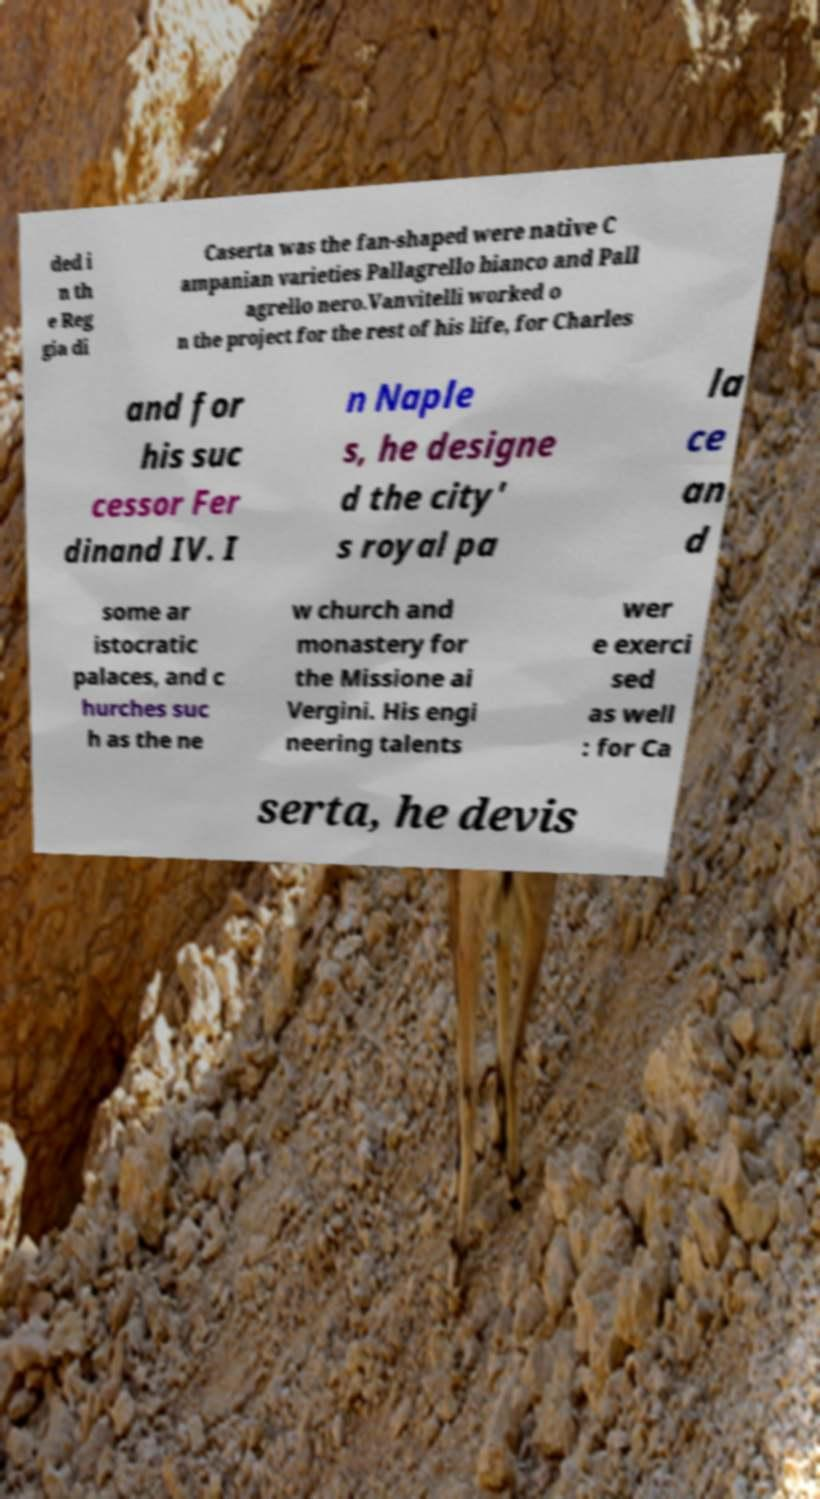Please read and relay the text visible in this image. What does it say? ded i n th e Reg gia di Caserta was the fan-shaped were native C ampanian varieties Pallagrello bianco and Pall agrello nero.Vanvitelli worked o n the project for the rest of his life, for Charles and for his suc cessor Fer dinand IV. I n Naple s, he designe d the city' s royal pa la ce an d some ar istocratic palaces, and c hurches suc h as the ne w church and monastery for the Missione ai Vergini. His engi neering talents wer e exerci sed as well : for Ca serta, he devis 